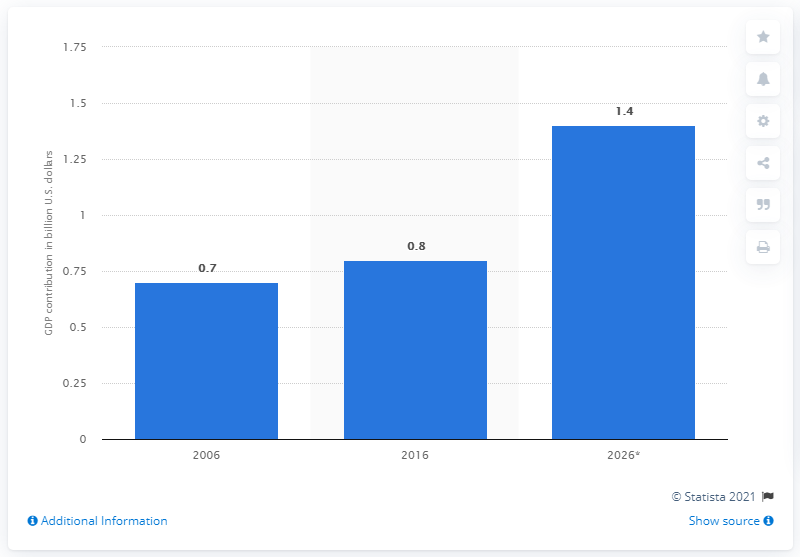Specify some key components in this picture. Durban's direct tourism contribution to the GDP of South Africa in 2026 was 1.4%. 